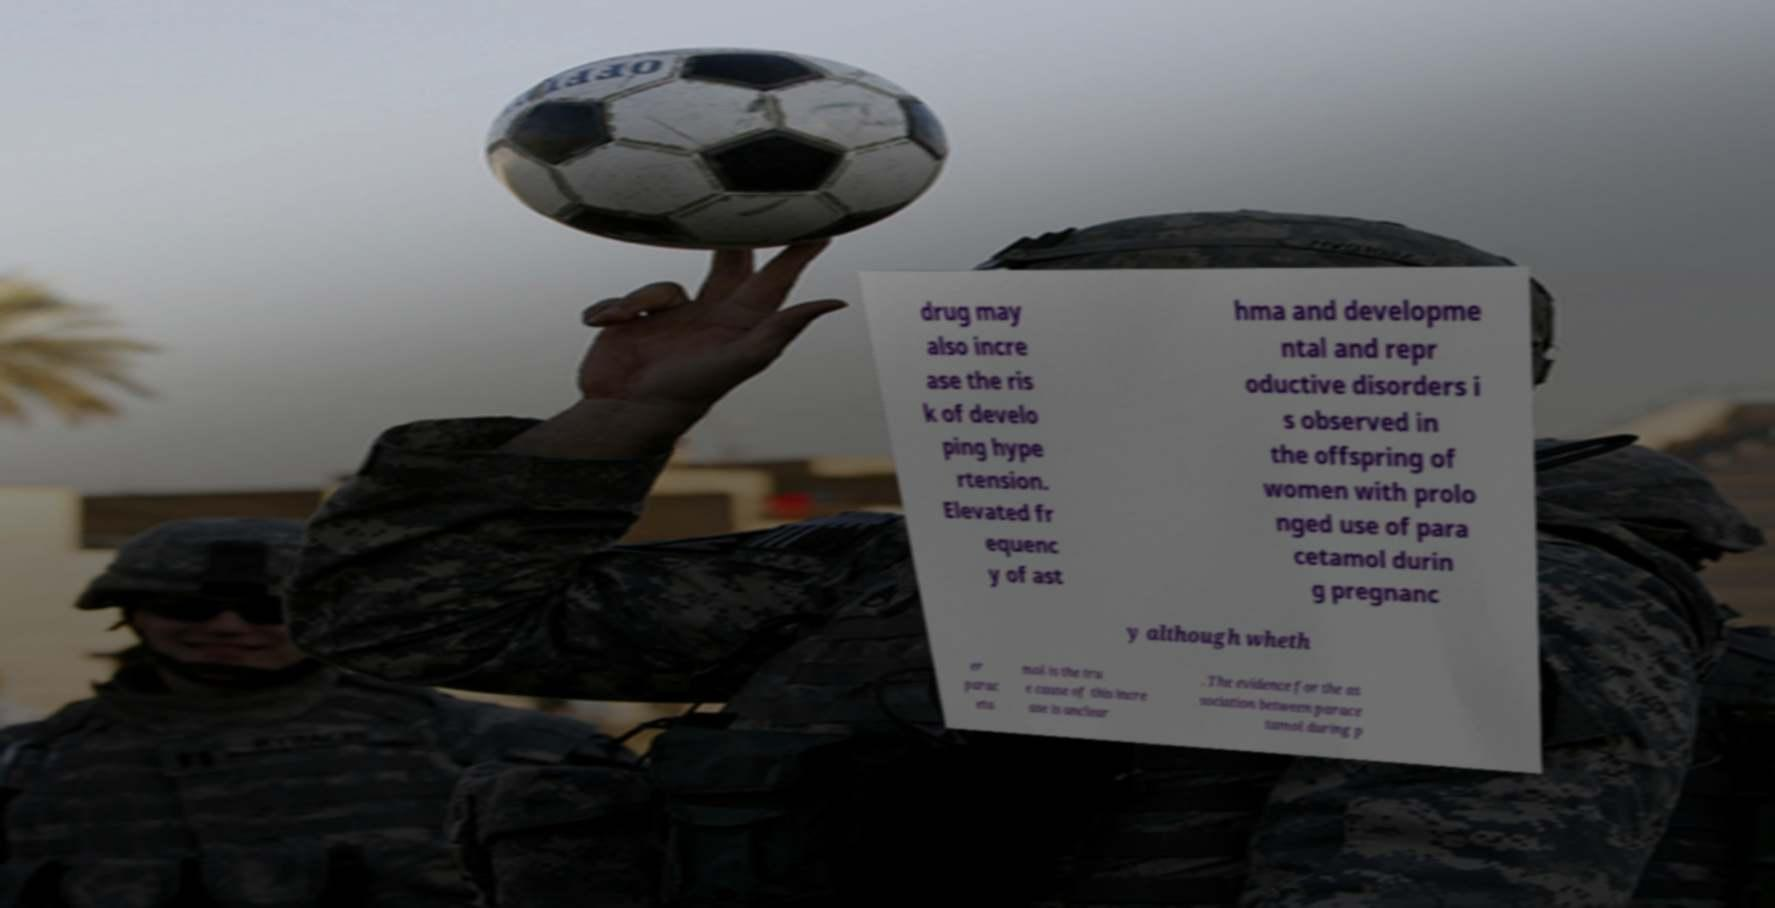Please identify and transcribe the text found in this image. drug may also incre ase the ris k of develo ping hype rtension. Elevated fr equenc y of ast hma and developme ntal and repr oductive disorders i s observed in the offspring of women with prolo nged use of para cetamol durin g pregnanc y although wheth er parac eta mol is the tru e cause of this incre ase is unclear . The evidence for the as sociation between parace tamol during p 